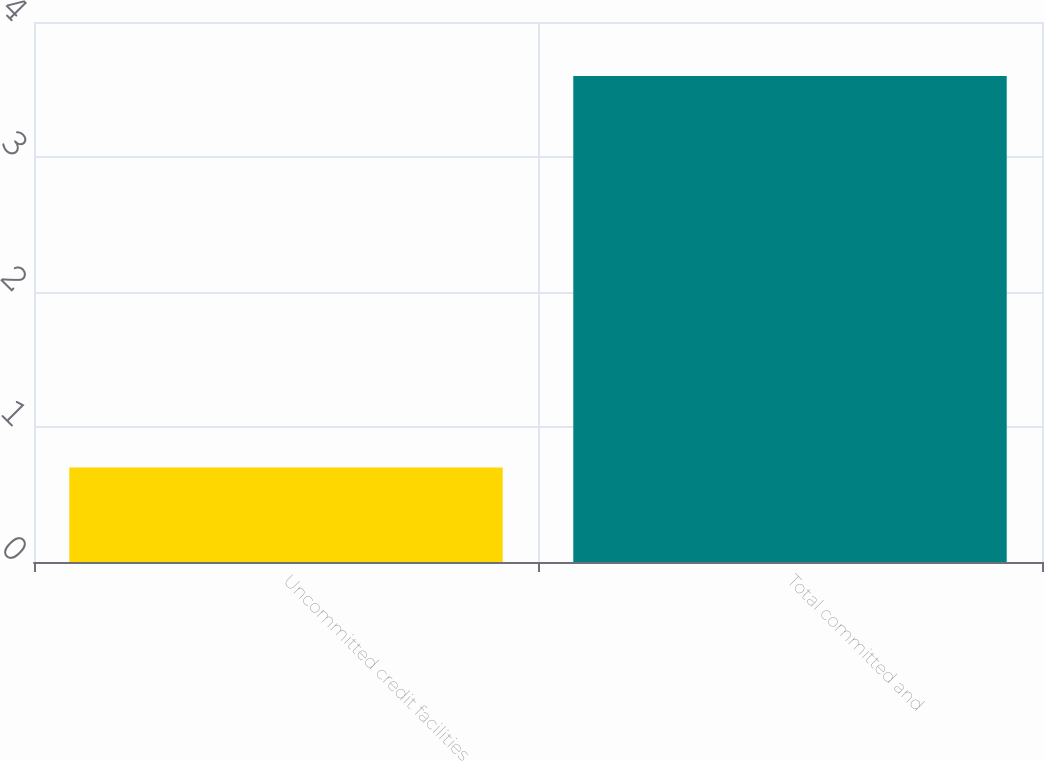<chart> <loc_0><loc_0><loc_500><loc_500><bar_chart><fcel>Uncommitted credit facilities<fcel>Total committed and<nl><fcel>0.7<fcel>3.6<nl></chart> 